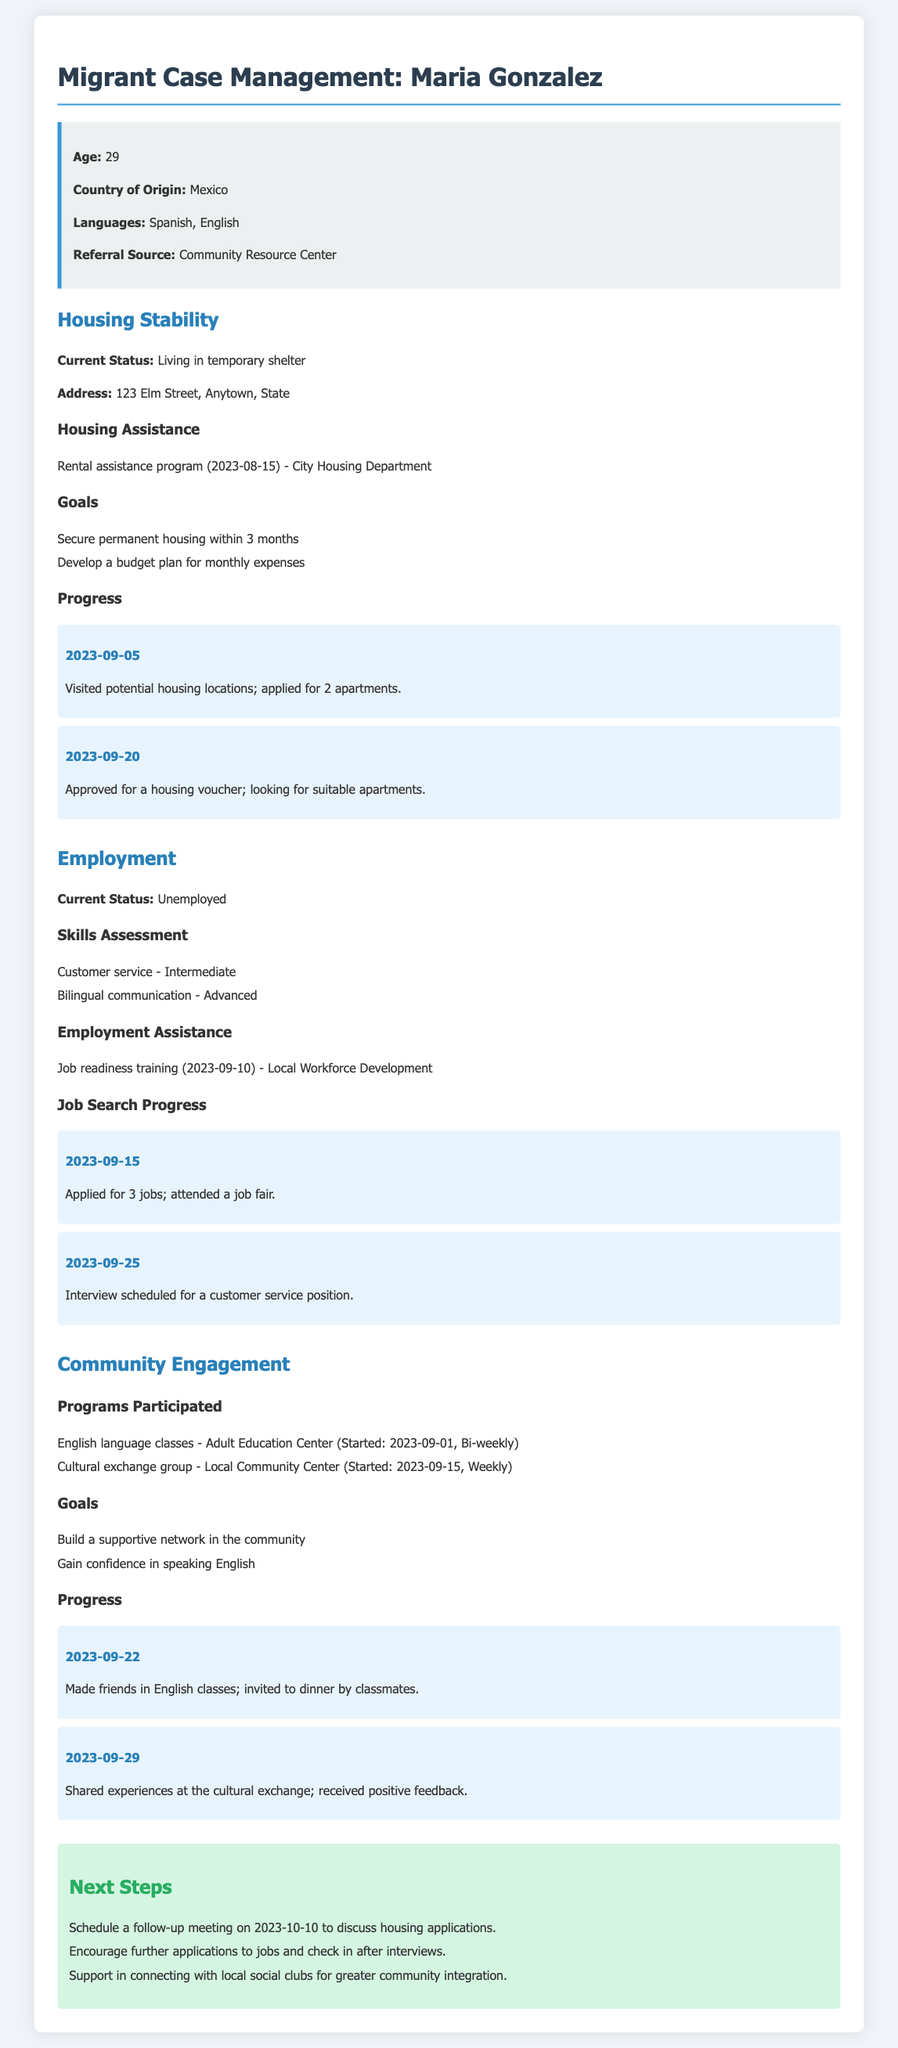What is the age of Maria Gonzalez? Maria Gonzalez's age is explicitly stated in the document.
Answer: 29 What is Maria's current housing status? The document provides her current living situation.
Answer: Living in temporary shelter Which language does Maria speak at an advanced level? The language proficiency listed in the document specifies her skills.
Answer: Bilingual communication What is the date when Maria applied for rental assistance? The date of the rental assistance program is mentioned in the document.
Answer: 2023-08-15 How many jobs did Maria apply for by September 15, 2023? The document outlines the number of job applications made by that date.
Answer: 3 jobs What is one of Maria's goals related to housing? Her goals for achieving housing stability are listed in the document.
Answer: Secure permanent housing within 3 months When did Maria start attending English language classes? The start date for her classes is provided in the community engagement section.
Answer: 2023-09-01 What type of training did Maria receive for employment? The document mentions the type of training she participated in.
Answer: Job readiness training What is the next step scheduled for Maria on October 10, 2023? The next steps section outlines her upcoming meetings or actions.
Answer: Schedule a follow-up meeting 